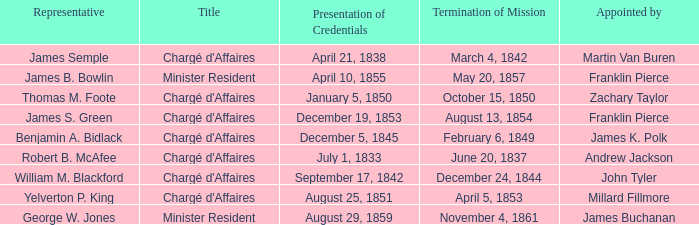What Title has a Termination of Mission of November 4, 1861? Minister Resident. 